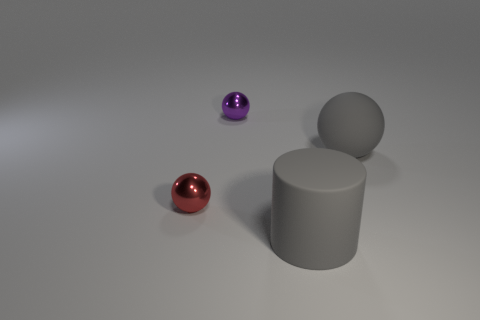Add 1 gray rubber cylinders. How many objects exist? 5 Subtract 3 balls. How many balls are left? 0 Subtract all red blocks. How many brown cylinders are left? 0 Subtract all matte balls. Subtract all shiny things. How many objects are left? 1 Add 4 small red metal balls. How many small red metal balls are left? 5 Add 2 cyan matte cylinders. How many cyan matte cylinders exist? 2 Subtract all purple spheres. How many spheres are left? 2 Subtract all tiny red balls. How many balls are left? 2 Subtract 0 red cubes. How many objects are left? 4 Subtract all balls. How many objects are left? 1 